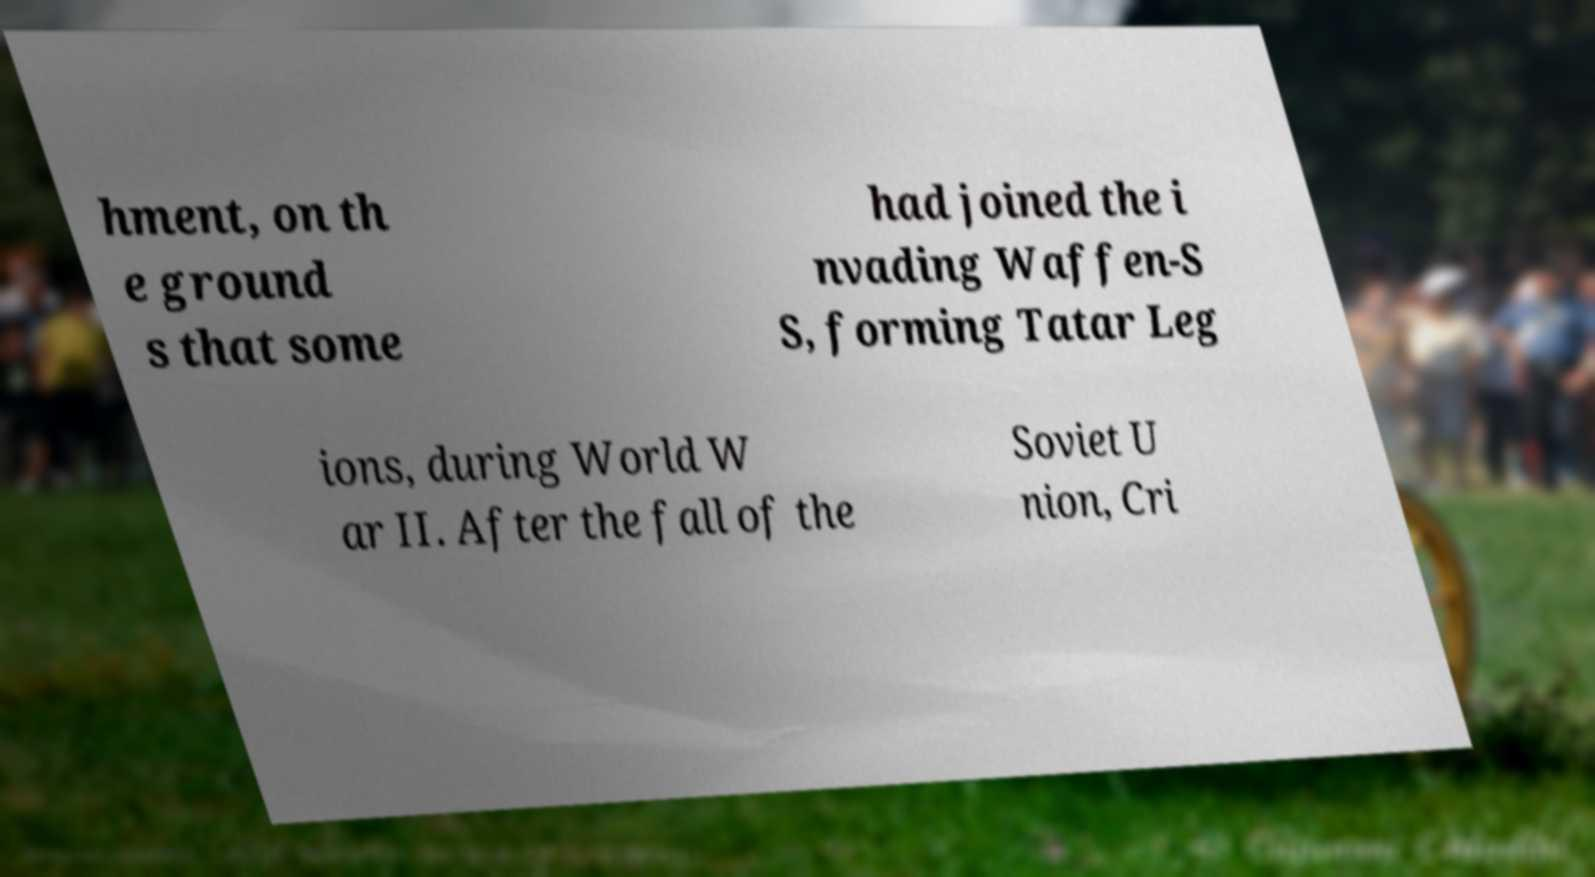What messages or text are displayed in this image? I need them in a readable, typed format. hment, on th e ground s that some had joined the i nvading Waffen-S S, forming Tatar Leg ions, during World W ar II. After the fall of the Soviet U nion, Cri 